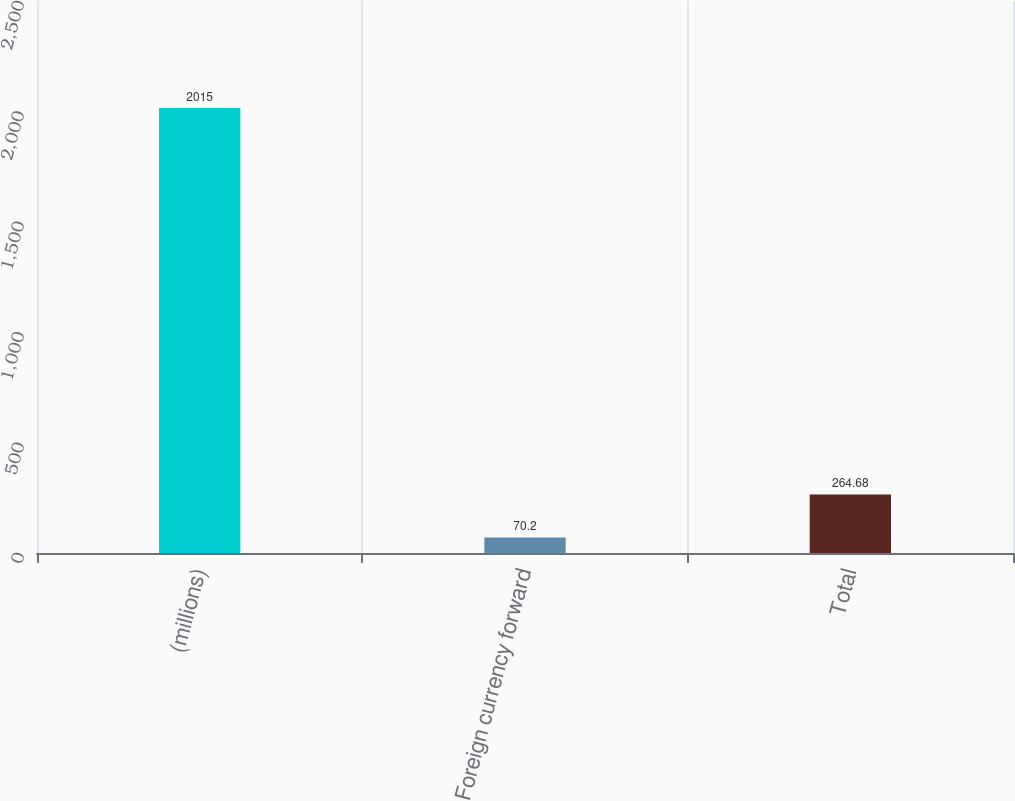Convert chart. <chart><loc_0><loc_0><loc_500><loc_500><bar_chart><fcel>(millions)<fcel>Foreign currency forward<fcel>Total<nl><fcel>2015<fcel>70.2<fcel>264.68<nl></chart> 